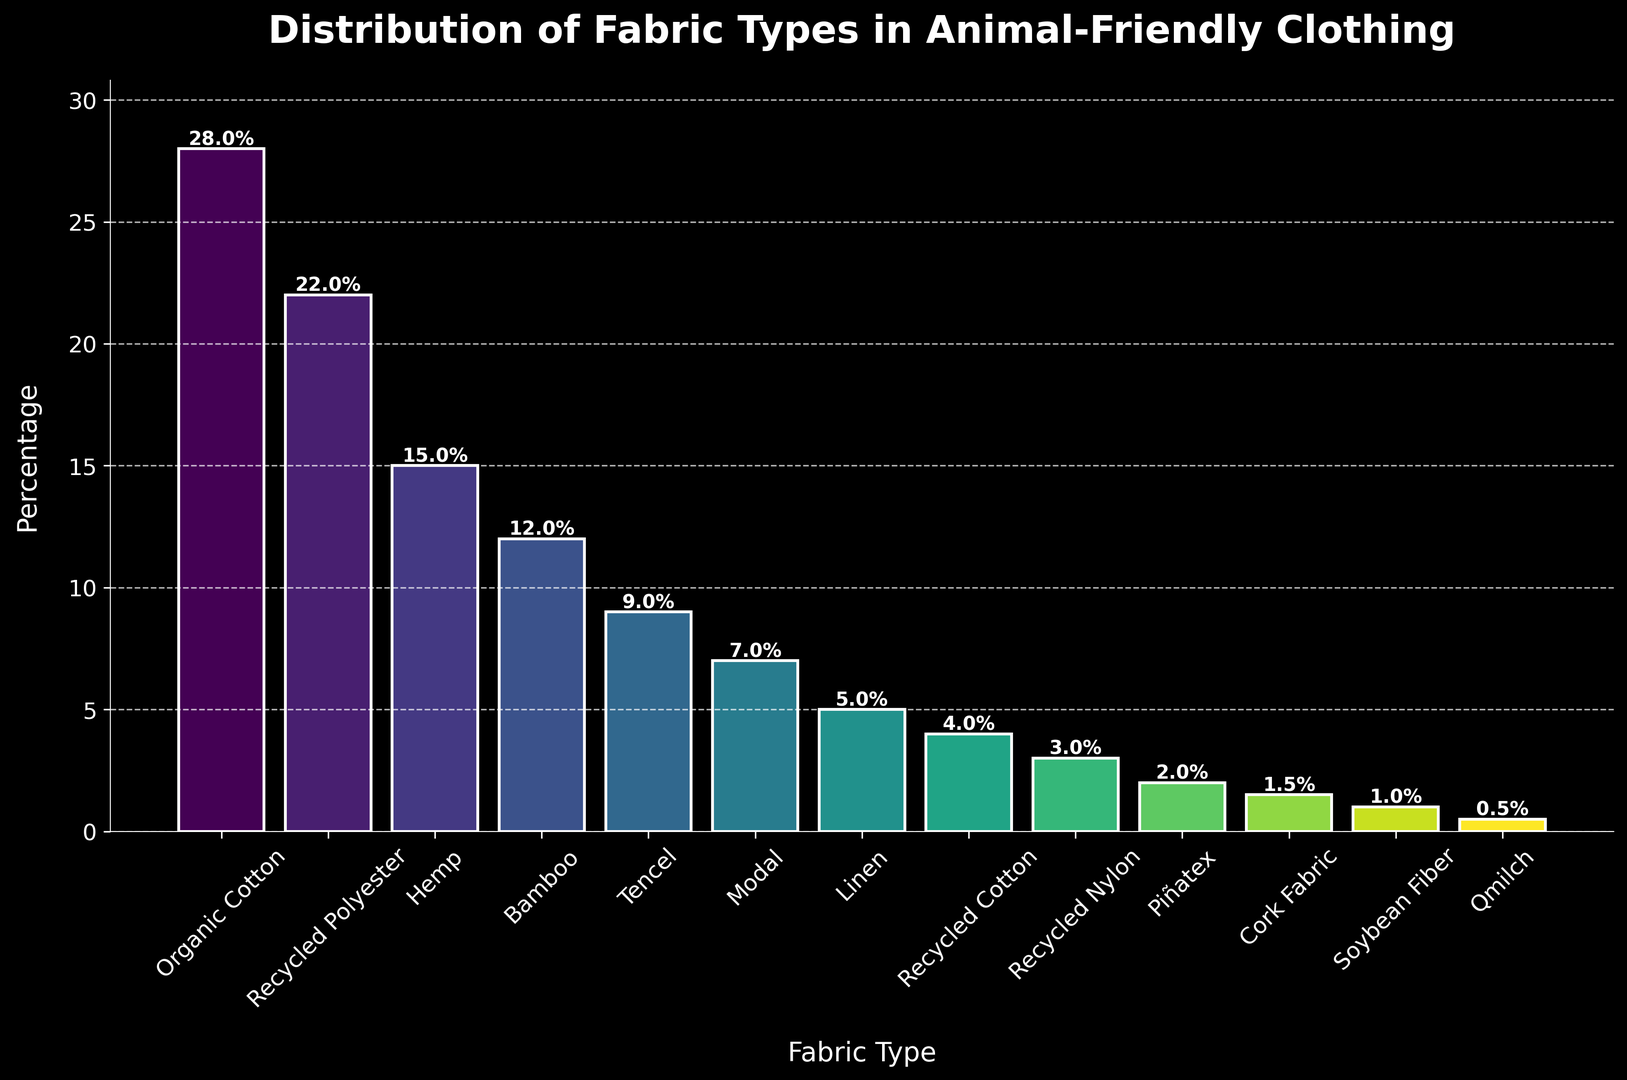What is the most commonly used fabric type in animal-friendly clothing production? Look at the bar with the highest percentage value. The tallest bar represents Organic Cotton with a percentage value of 28%, indicating that it is the most commonly used fabric type.
Answer: Organic Cotton How many fabric types have a percentage above 20%? Identify the bars with percentage values above 20%. Organic Cotton and Recycled Polyester have percentages of 28% and 22%, respectively.
Answer: 2 Which fabric type has the lowest percentage in animal-friendly clothing production? Locate the bar with the lowest height. Qmilch has the smallest bar with a percentage of 0.5%.
Answer: Qmilch What is the combined percentage of Hemp and Bamboo fabric types? Add the percentages of Hemp and Bamboo. Hemp has 15% and Bamboo has 12%. The combined percentage is 15% + 12% = 27%.
Answer: 27% Between Linen and Recycled Cotton, which fabric type is used more extensively? Compare the heights of the bars for Linen and Recycled Cotton. Linen has a percentage of 5%, while Recycled Cotton has 4%. Therefore, Linen is used more extensively.
Answer: Linen What is the percentage difference between Tencel and Modal fabric types? Subtract the percentage of Modal from Tencel. Tencel has 9% and Modal has 7%. The difference is 9% - 7% = 2%.
Answer: 2% How does the usage of Bamboo compare visually to Recycled Polyester? Visually compare the heights of the bars for Bamboo and Recycled Polyester. The bar for Bamboo is shorter than the bar for Recycled Polyester, indicating a lower percentage for Bamboo.
Answer: Lower Which fabric type is closest to 10% in terms of usage? Identify the bar that is closest to the 10% mark. Tencel has a percentage of 9%, which is closest to 10%.
Answer: Tencel What do the colors on the bars represent? The colors are used to differentiate between various fabric types. Each bar is a different color to visually distinguish one fabric type from another.
Answer: Different fabric types If you combine the percentages of Organic Cotton, Recycled Polyester, and Hemp, what is the total percentage? Add the percentages of Organic Cotton, Recycled Polyester, and Hemp. Organic Cotton is 28%, Recycled Polyester is 22%, and Hemp is 15%. The total percentage is 28% + 22% + 15% = 65%.
Answer: 65% 